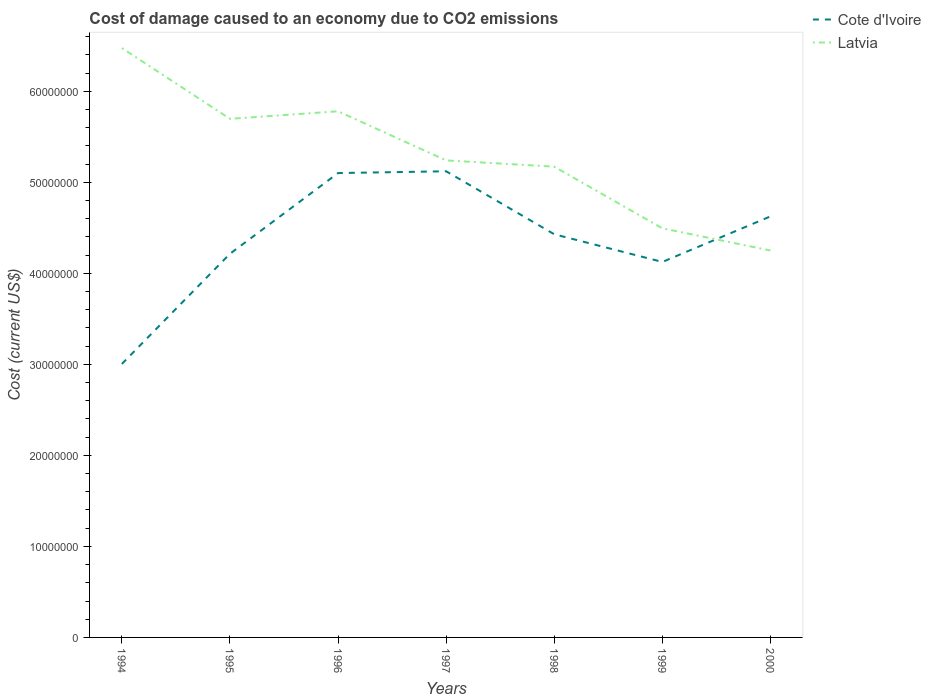Does the line corresponding to Cote d'Ivoire intersect with the line corresponding to Latvia?
Provide a short and direct response. Yes. Is the number of lines equal to the number of legend labels?
Provide a succinct answer. Yes. Across all years, what is the maximum cost of damage caused due to CO2 emissisons in Cote d'Ivoire?
Your answer should be compact. 3.00e+07. In which year was the cost of damage caused due to CO2 emissisons in Latvia maximum?
Offer a very short reply. 2000. What is the total cost of damage caused due to CO2 emissisons in Cote d'Ivoire in the graph?
Your answer should be very brief. -1.96e+06. What is the difference between the highest and the second highest cost of damage caused due to CO2 emissisons in Latvia?
Ensure brevity in your answer.  2.22e+07. What is the difference between the highest and the lowest cost of damage caused due to CO2 emissisons in Cote d'Ivoire?
Provide a short and direct response. 4. How many years are there in the graph?
Your answer should be very brief. 7. Are the values on the major ticks of Y-axis written in scientific E-notation?
Your response must be concise. No. What is the title of the graph?
Your response must be concise. Cost of damage caused to an economy due to CO2 emissions. What is the label or title of the Y-axis?
Your answer should be compact. Cost (current US$). What is the Cost (current US$) of Cote d'Ivoire in 1994?
Keep it short and to the point. 3.00e+07. What is the Cost (current US$) of Latvia in 1994?
Provide a short and direct response. 6.47e+07. What is the Cost (current US$) of Cote d'Ivoire in 1995?
Offer a very short reply. 4.21e+07. What is the Cost (current US$) of Latvia in 1995?
Offer a terse response. 5.70e+07. What is the Cost (current US$) in Cote d'Ivoire in 1996?
Provide a succinct answer. 5.10e+07. What is the Cost (current US$) in Latvia in 1996?
Your answer should be compact. 5.78e+07. What is the Cost (current US$) in Cote d'Ivoire in 1997?
Give a very brief answer. 5.12e+07. What is the Cost (current US$) in Latvia in 1997?
Your answer should be compact. 5.24e+07. What is the Cost (current US$) of Cote d'Ivoire in 1998?
Ensure brevity in your answer.  4.43e+07. What is the Cost (current US$) of Latvia in 1998?
Provide a succinct answer. 5.17e+07. What is the Cost (current US$) of Cote d'Ivoire in 1999?
Give a very brief answer. 4.12e+07. What is the Cost (current US$) in Latvia in 1999?
Your response must be concise. 4.49e+07. What is the Cost (current US$) of Cote d'Ivoire in 2000?
Offer a terse response. 4.63e+07. What is the Cost (current US$) in Latvia in 2000?
Provide a succinct answer. 4.25e+07. Across all years, what is the maximum Cost (current US$) in Cote d'Ivoire?
Your answer should be very brief. 5.12e+07. Across all years, what is the maximum Cost (current US$) of Latvia?
Your response must be concise. 6.47e+07. Across all years, what is the minimum Cost (current US$) of Cote d'Ivoire?
Your response must be concise. 3.00e+07. Across all years, what is the minimum Cost (current US$) in Latvia?
Provide a short and direct response. 4.25e+07. What is the total Cost (current US$) of Cote d'Ivoire in the graph?
Your answer should be very brief. 3.06e+08. What is the total Cost (current US$) in Latvia in the graph?
Ensure brevity in your answer.  3.71e+08. What is the difference between the Cost (current US$) in Cote d'Ivoire in 1994 and that in 1995?
Make the answer very short. -1.21e+07. What is the difference between the Cost (current US$) of Latvia in 1994 and that in 1995?
Provide a short and direct response. 7.78e+06. What is the difference between the Cost (current US$) of Cote d'Ivoire in 1994 and that in 1996?
Your response must be concise. -2.10e+07. What is the difference between the Cost (current US$) in Latvia in 1994 and that in 1996?
Provide a succinct answer. 6.95e+06. What is the difference between the Cost (current US$) of Cote d'Ivoire in 1994 and that in 1997?
Provide a succinct answer. -2.12e+07. What is the difference between the Cost (current US$) of Latvia in 1994 and that in 1997?
Offer a terse response. 1.23e+07. What is the difference between the Cost (current US$) of Cote d'Ivoire in 1994 and that in 1998?
Your response must be concise. -1.42e+07. What is the difference between the Cost (current US$) in Latvia in 1994 and that in 1998?
Provide a succinct answer. 1.30e+07. What is the difference between the Cost (current US$) of Cote d'Ivoire in 1994 and that in 1999?
Offer a very short reply. -1.12e+07. What is the difference between the Cost (current US$) of Latvia in 1994 and that in 1999?
Make the answer very short. 1.98e+07. What is the difference between the Cost (current US$) of Cote d'Ivoire in 1994 and that in 2000?
Keep it short and to the point. -1.62e+07. What is the difference between the Cost (current US$) of Latvia in 1994 and that in 2000?
Your answer should be very brief. 2.22e+07. What is the difference between the Cost (current US$) in Cote d'Ivoire in 1995 and that in 1996?
Ensure brevity in your answer.  -8.86e+06. What is the difference between the Cost (current US$) in Latvia in 1995 and that in 1996?
Provide a short and direct response. -8.29e+05. What is the difference between the Cost (current US$) in Cote d'Ivoire in 1995 and that in 1997?
Offer a terse response. -9.06e+06. What is the difference between the Cost (current US$) in Latvia in 1995 and that in 1997?
Give a very brief answer. 4.57e+06. What is the difference between the Cost (current US$) of Cote d'Ivoire in 1995 and that in 1998?
Give a very brief answer. -2.14e+06. What is the difference between the Cost (current US$) of Latvia in 1995 and that in 1998?
Offer a terse response. 5.26e+06. What is the difference between the Cost (current US$) in Cote d'Ivoire in 1995 and that in 1999?
Provide a short and direct response. 9.00e+05. What is the difference between the Cost (current US$) of Latvia in 1995 and that in 1999?
Give a very brief answer. 1.20e+07. What is the difference between the Cost (current US$) of Cote d'Ivoire in 1995 and that in 2000?
Offer a terse response. -4.11e+06. What is the difference between the Cost (current US$) in Latvia in 1995 and that in 2000?
Provide a short and direct response. 1.45e+07. What is the difference between the Cost (current US$) of Cote d'Ivoire in 1996 and that in 1997?
Your answer should be compact. -1.96e+05. What is the difference between the Cost (current US$) of Latvia in 1996 and that in 1997?
Give a very brief answer. 5.40e+06. What is the difference between the Cost (current US$) of Cote d'Ivoire in 1996 and that in 1998?
Your response must be concise. 6.72e+06. What is the difference between the Cost (current US$) of Latvia in 1996 and that in 1998?
Offer a very short reply. 6.08e+06. What is the difference between the Cost (current US$) in Cote d'Ivoire in 1996 and that in 1999?
Your answer should be compact. 9.76e+06. What is the difference between the Cost (current US$) in Latvia in 1996 and that in 1999?
Make the answer very short. 1.29e+07. What is the difference between the Cost (current US$) of Cote d'Ivoire in 1996 and that in 2000?
Ensure brevity in your answer.  4.76e+06. What is the difference between the Cost (current US$) of Latvia in 1996 and that in 2000?
Provide a succinct answer. 1.53e+07. What is the difference between the Cost (current US$) of Cote d'Ivoire in 1997 and that in 1998?
Provide a succinct answer. 6.92e+06. What is the difference between the Cost (current US$) in Latvia in 1997 and that in 1998?
Offer a terse response. 6.89e+05. What is the difference between the Cost (current US$) of Cote d'Ivoire in 1997 and that in 1999?
Your answer should be very brief. 9.96e+06. What is the difference between the Cost (current US$) of Latvia in 1997 and that in 1999?
Offer a terse response. 7.46e+06. What is the difference between the Cost (current US$) in Cote d'Ivoire in 1997 and that in 2000?
Your answer should be compact. 4.95e+06. What is the difference between the Cost (current US$) in Latvia in 1997 and that in 2000?
Provide a succinct answer. 9.90e+06. What is the difference between the Cost (current US$) of Cote d'Ivoire in 1998 and that in 1999?
Make the answer very short. 3.04e+06. What is the difference between the Cost (current US$) of Latvia in 1998 and that in 1999?
Offer a very short reply. 6.77e+06. What is the difference between the Cost (current US$) of Cote d'Ivoire in 1998 and that in 2000?
Keep it short and to the point. -1.96e+06. What is the difference between the Cost (current US$) in Latvia in 1998 and that in 2000?
Offer a very short reply. 9.21e+06. What is the difference between the Cost (current US$) of Cote d'Ivoire in 1999 and that in 2000?
Your answer should be very brief. -5.01e+06. What is the difference between the Cost (current US$) in Latvia in 1999 and that in 2000?
Your answer should be very brief. 2.43e+06. What is the difference between the Cost (current US$) in Cote d'Ivoire in 1994 and the Cost (current US$) in Latvia in 1995?
Offer a very short reply. -2.69e+07. What is the difference between the Cost (current US$) of Cote d'Ivoire in 1994 and the Cost (current US$) of Latvia in 1996?
Keep it short and to the point. -2.78e+07. What is the difference between the Cost (current US$) in Cote d'Ivoire in 1994 and the Cost (current US$) in Latvia in 1997?
Provide a succinct answer. -2.24e+07. What is the difference between the Cost (current US$) in Cote d'Ivoire in 1994 and the Cost (current US$) in Latvia in 1998?
Provide a short and direct response. -2.17e+07. What is the difference between the Cost (current US$) of Cote d'Ivoire in 1994 and the Cost (current US$) of Latvia in 1999?
Your response must be concise. -1.49e+07. What is the difference between the Cost (current US$) in Cote d'Ivoire in 1994 and the Cost (current US$) in Latvia in 2000?
Offer a terse response. -1.25e+07. What is the difference between the Cost (current US$) in Cote d'Ivoire in 1995 and the Cost (current US$) in Latvia in 1996?
Keep it short and to the point. -1.57e+07. What is the difference between the Cost (current US$) in Cote d'Ivoire in 1995 and the Cost (current US$) in Latvia in 1997?
Provide a succinct answer. -1.03e+07. What is the difference between the Cost (current US$) in Cote d'Ivoire in 1995 and the Cost (current US$) in Latvia in 1998?
Offer a very short reply. -9.57e+06. What is the difference between the Cost (current US$) in Cote d'Ivoire in 1995 and the Cost (current US$) in Latvia in 1999?
Offer a terse response. -2.79e+06. What is the difference between the Cost (current US$) of Cote d'Ivoire in 1995 and the Cost (current US$) of Latvia in 2000?
Your response must be concise. -3.60e+05. What is the difference between the Cost (current US$) of Cote d'Ivoire in 1996 and the Cost (current US$) of Latvia in 1997?
Keep it short and to the point. -1.39e+06. What is the difference between the Cost (current US$) in Cote d'Ivoire in 1996 and the Cost (current US$) in Latvia in 1998?
Ensure brevity in your answer.  -7.02e+05. What is the difference between the Cost (current US$) of Cote d'Ivoire in 1996 and the Cost (current US$) of Latvia in 1999?
Provide a succinct answer. 6.07e+06. What is the difference between the Cost (current US$) of Cote d'Ivoire in 1996 and the Cost (current US$) of Latvia in 2000?
Provide a short and direct response. 8.50e+06. What is the difference between the Cost (current US$) of Cote d'Ivoire in 1997 and the Cost (current US$) of Latvia in 1998?
Make the answer very short. -5.06e+05. What is the difference between the Cost (current US$) of Cote d'Ivoire in 1997 and the Cost (current US$) of Latvia in 1999?
Provide a succinct answer. 6.27e+06. What is the difference between the Cost (current US$) in Cote d'Ivoire in 1997 and the Cost (current US$) in Latvia in 2000?
Your answer should be very brief. 8.70e+06. What is the difference between the Cost (current US$) of Cote d'Ivoire in 1998 and the Cost (current US$) of Latvia in 1999?
Your answer should be compact. -6.51e+05. What is the difference between the Cost (current US$) in Cote d'Ivoire in 1998 and the Cost (current US$) in Latvia in 2000?
Offer a terse response. 1.78e+06. What is the difference between the Cost (current US$) in Cote d'Ivoire in 1999 and the Cost (current US$) in Latvia in 2000?
Ensure brevity in your answer.  -1.26e+06. What is the average Cost (current US$) of Cote d'Ivoire per year?
Offer a terse response. 4.37e+07. What is the average Cost (current US$) of Latvia per year?
Your answer should be very brief. 5.30e+07. In the year 1994, what is the difference between the Cost (current US$) of Cote d'Ivoire and Cost (current US$) of Latvia?
Provide a short and direct response. -3.47e+07. In the year 1995, what is the difference between the Cost (current US$) of Cote d'Ivoire and Cost (current US$) of Latvia?
Offer a terse response. -1.48e+07. In the year 1996, what is the difference between the Cost (current US$) in Cote d'Ivoire and Cost (current US$) in Latvia?
Your answer should be compact. -6.79e+06. In the year 1997, what is the difference between the Cost (current US$) in Cote d'Ivoire and Cost (current US$) in Latvia?
Give a very brief answer. -1.19e+06. In the year 1998, what is the difference between the Cost (current US$) of Cote d'Ivoire and Cost (current US$) of Latvia?
Keep it short and to the point. -7.42e+06. In the year 1999, what is the difference between the Cost (current US$) in Cote d'Ivoire and Cost (current US$) in Latvia?
Ensure brevity in your answer.  -3.69e+06. In the year 2000, what is the difference between the Cost (current US$) of Cote d'Ivoire and Cost (current US$) of Latvia?
Keep it short and to the point. 3.75e+06. What is the ratio of the Cost (current US$) in Cote d'Ivoire in 1994 to that in 1995?
Ensure brevity in your answer.  0.71. What is the ratio of the Cost (current US$) of Latvia in 1994 to that in 1995?
Provide a short and direct response. 1.14. What is the ratio of the Cost (current US$) in Cote d'Ivoire in 1994 to that in 1996?
Your answer should be very brief. 0.59. What is the ratio of the Cost (current US$) of Latvia in 1994 to that in 1996?
Make the answer very short. 1.12. What is the ratio of the Cost (current US$) in Cote d'Ivoire in 1994 to that in 1997?
Offer a very short reply. 0.59. What is the ratio of the Cost (current US$) of Latvia in 1994 to that in 1997?
Your answer should be compact. 1.24. What is the ratio of the Cost (current US$) of Cote d'Ivoire in 1994 to that in 1998?
Provide a succinct answer. 0.68. What is the ratio of the Cost (current US$) in Latvia in 1994 to that in 1998?
Your answer should be compact. 1.25. What is the ratio of the Cost (current US$) of Cote d'Ivoire in 1994 to that in 1999?
Provide a succinct answer. 0.73. What is the ratio of the Cost (current US$) in Latvia in 1994 to that in 1999?
Keep it short and to the point. 1.44. What is the ratio of the Cost (current US$) in Cote d'Ivoire in 1994 to that in 2000?
Ensure brevity in your answer.  0.65. What is the ratio of the Cost (current US$) of Latvia in 1994 to that in 2000?
Your answer should be very brief. 1.52. What is the ratio of the Cost (current US$) in Cote d'Ivoire in 1995 to that in 1996?
Provide a short and direct response. 0.83. What is the ratio of the Cost (current US$) of Latvia in 1995 to that in 1996?
Keep it short and to the point. 0.99. What is the ratio of the Cost (current US$) in Cote d'Ivoire in 1995 to that in 1997?
Keep it short and to the point. 0.82. What is the ratio of the Cost (current US$) in Latvia in 1995 to that in 1997?
Your response must be concise. 1.09. What is the ratio of the Cost (current US$) of Cote d'Ivoire in 1995 to that in 1998?
Your answer should be compact. 0.95. What is the ratio of the Cost (current US$) in Latvia in 1995 to that in 1998?
Your answer should be compact. 1.1. What is the ratio of the Cost (current US$) of Cote d'Ivoire in 1995 to that in 1999?
Give a very brief answer. 1.02. What is the ratio of the Cost (current US$) in Latvia in 1995 to that in 1999?
Provide a short and direct response. 1.27. What is the ratio of the Cost (current US$) in Cote d'Ivoire in 1995 to that in 2000?
Your answer should be compact. 0.91. What is the ratio of the Cost (current US$) in Latvia in 1995 to that in 2000?
Your answer should be very brief. 1.34. What is the ratio of the Cost (current US$) in Cote d'Ivoire in 1996 to that in 1997?
Provide a succinct answer. 1. What is the ratio of the Cost (current US$) in Latvia in 1996 to that in 1997?
Keep it short and to the point. 1.1. What is the ratio of the Cost (current US$) in Cote d'Ivoire in 1996 to that in 1998?
Your answer should be compact. 1.15. What is the ratio of the Cost (current US$) in Latvia in 1996 to that in 1998?
Your answer should be compact. 1.12. What is the ratio of the Cost (current US$) in Cote d'Ivoire in 1996 to that in 1999?
Offer a very short reply. 1.24. What is the ratio of the Cost (current US$) in Latvia in 1996 to that in 1999?
Provide a short and direct response. 1.29. What is the ratio of the Cost (current US$) of Cote d'Ivoire in 1996 to that in 2000?
Provide a succinct answer. 1.1. What is the ratio of the Cost (current US$) in Latvia in 1996 to that in 2000?
Give a very brief answer. 1.36. What is the ratio of the Cost (current US$) of Cote d'Ivoire in 1997 to that in 1998?
Your answer should be compact. 1.16. What is the ratio of the Cost (current US$) in Latvia in 1997 to that in 1998?
Provide a short and direct response. 1.01. What is the ratio of the Cost (current US$) in Cote d'Ivoire in 1997 to that in 1999?
Give a very brief answer. 1.24. What is the ratio of the Cost (current US$) in Latvia in 1997 to that in 1999?
Give a very brief answer. 1.17. What is the ratio of the Cost (current US$) in Cote d'Ivoire in 1997 to that in 2000?
Offer a very short reply. 1.11. What is the ratio of the Cost (current US$) of Latvia in 1997 to that in 2000?
Your response must be concise. 1.23. What is the ratio of the Cost (current US$) in Cote d'Ivoire in 1998 to that in 1999?
Offer a terse response. 1.07. What is the ratio of the Cost (current US$) of Latvia in 1998 to that in 1999?
Your answer should be compact. 1.15. What is the ratio of the Cost (current US$) of Cote d'Ivoire in 1998 to that in 2000?
Provide a short and direct response. 0.96. What is the ratio of the Cost (current US$) of Latvia in 1998 to that in 2000?
Provide a succinct answer. 1.22. What is the ratio of the Cost (current US$) of Cote d'Ivoire in 1999 to that in 2000?
Your response must be concise. 0.89. What is the ratio of the Cost (current US$) of Latvia in 1999 to that in 2000?
Your response must be concise. 1.06. What is the difference between the highest and the second highest Cost (current US$) in Cote d'Ivoire?
Your response must be concise. 1.96e+05. What is the difference between the highest and the second highest Cost (current US$) of Latvia?
Give a very brief answer. 6.95e+06. What is the difference between the highest and the lowest Cost (current US$) in Cote d'Ivoire?
Offer a very short reply. 2.12e+07. What is the difference between the highest and the lowest Cost (current US$) of Latvia?
Provide a short and direct response. 2.22e+07. 